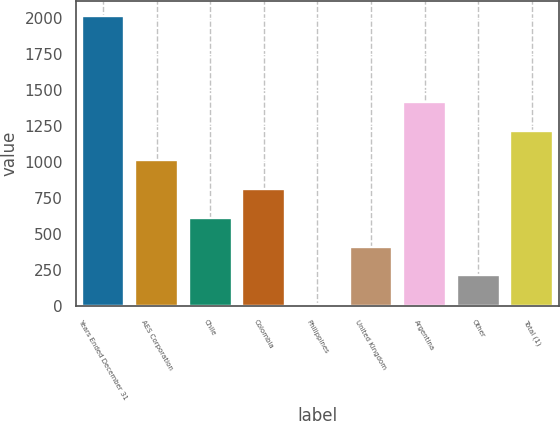Convert chart to OTSL. <chart><loc_0><loc_0><loc_500><loc_500><bar_chart><fcel>Years Ended December 31<fcel>AES Corporation<fcel>Chile<fcel>Colombia<fcel>Philippines<fcel>United Kingdom<fcel>Argentina<fcel>Other<fcel>Total (1)<nl><fcel>2015<fcel>1011.5<fcel>610.1<fcel>810.8<fcel>8<fcel>409.4<fcel>1412.9<fcel>208.7<fcel>1212.2<nl></chart> 